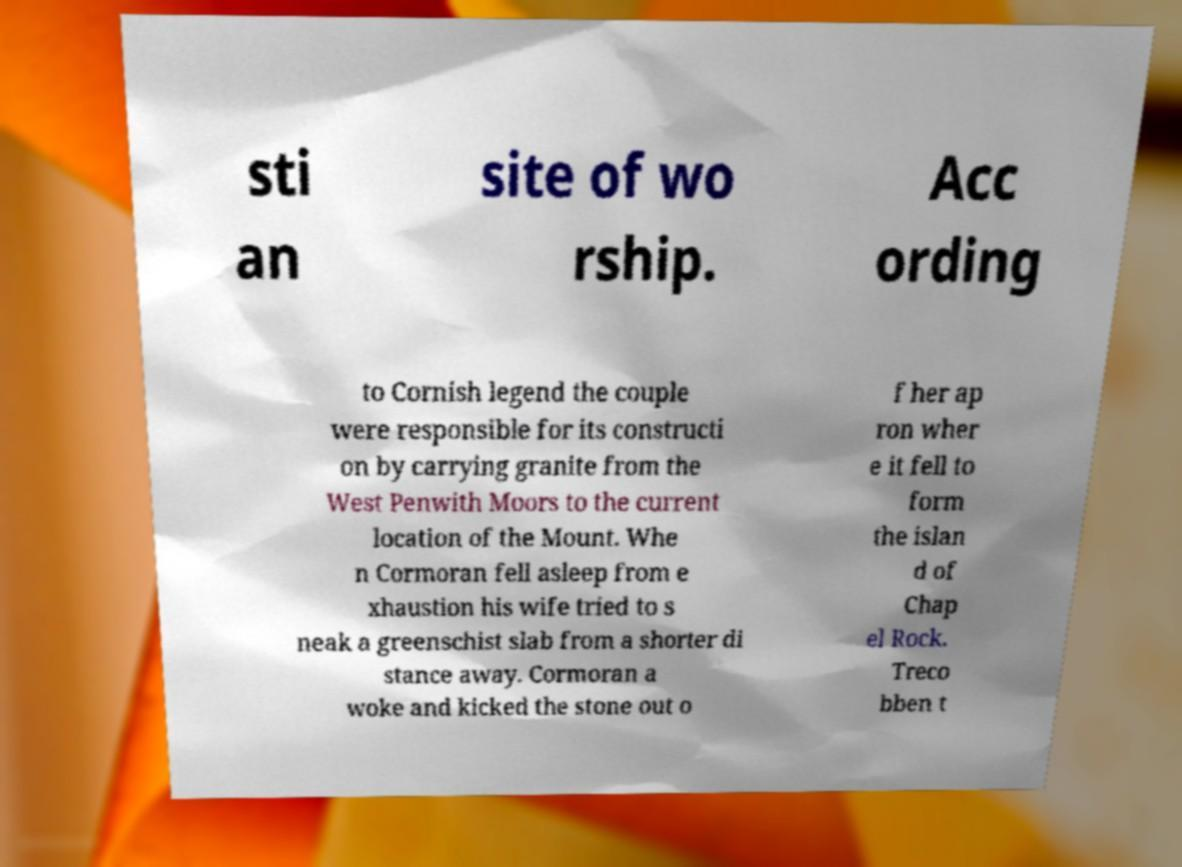There's text embedded in this image that I need extracted. Can you transcribe it verbatim? sti an site of wo rship. Acc ording to Cornish legend the couple were responsible for its constructi on by carrying granite from the West Penwith Moors to the current location of the Mount. Whe n Cormoran fell asleep from e xhaustion his wife tried to s neak a greenschist slab from a shorter di stance away. Cormoran a woke and kicked the stone out o f her ap ron wher e it fell to form the islan d of Chap el Rock. Treco bben t 